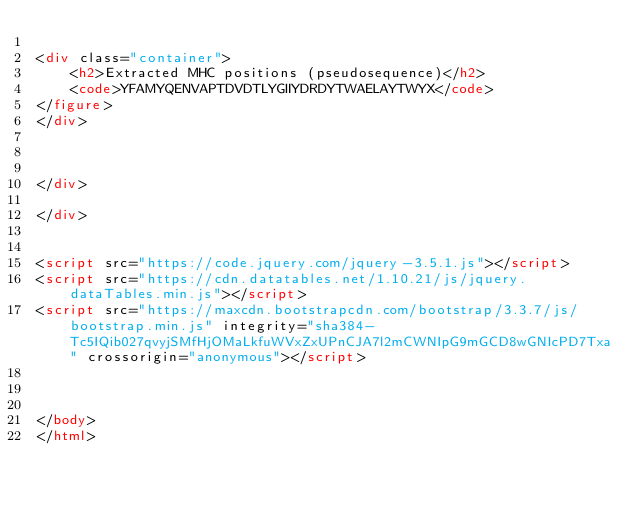Convert code to text. <code><loc_0><loc_0><loc_500><loc_500><_HTML_>
<div class="container">
    <h2>Extracted MHC positions (pseudosequence)</h2>
    <code>YFAMYQENVAPTDVDTLYGIIYDRDYTWAELAYTWYX</code>
</figure>
</div>



</div>

</div>


<script src="https://code.jquery.com/jquery-3.5.1.js"></script>
<script src="https://cdn.datatables.net/1.10.21/js/jquery.dataTables.min.js"></script>
<script src="https://maxcdn.bootstrapcdn.com/bootstrap/3.3.7/js/bootstrap.min.js" integrity="sha384-Tc5IQib027qvyjSMfHjOMaLkfuWVxZxUPnCJA7l2mCWNIpG9mGCD8wGNIcPD7Txa" crossorigin="anonymous"></script>



</body>
</html></code> 